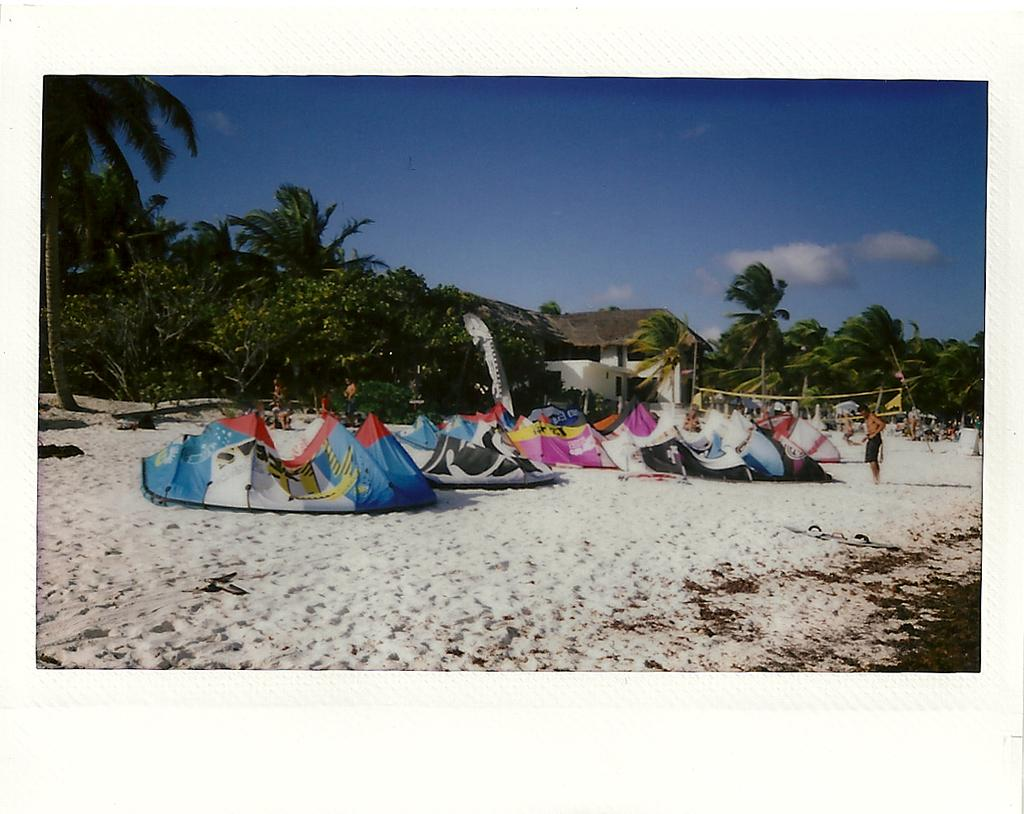What type of structures can be seen on the sand in the image? There are tents on the sand in the image. What are the people in the image doing? The people are standing at the back side in the image. What can be seen in the background of the image? There are trees, buildings, and the sky visible in the background of the image. What type of disease is being treated in the image? There is no indication of a disease or treatment in the image; it features tents, people, and background elements. What type of juice is being served in the image? There is no juice or serving activity present in the image. 